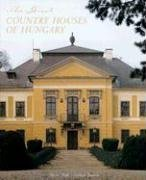Who wrote this book?
Answer the question using a single word or phrase. Michael Pratt What is the title of this book? The Great Country Houses of Hungary What type of book is this? Travel Is this book related to Travel? Yes Is this book related to Politics & Social Sciences? No 